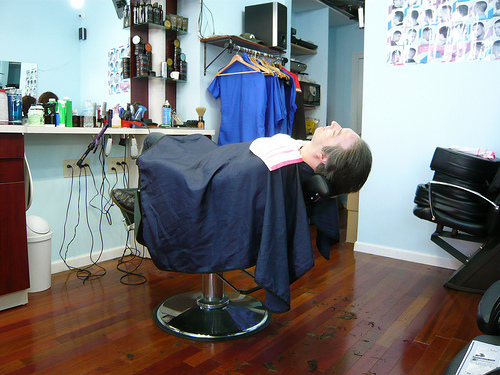<image>
Is the person on the ground? No. The person is not positioned on the ground. They may be near each other, but the person is not supported by or resting on top of the ground. Where is the man in relation to the chair? Is it behind the chair? No. The man is not behind the chair. From this viewpoint, the man appears to be positioned elsewhere in the scene. Is there a shirt next to the glass? No. The shirt is not positioned next to the glass. They are located in different areas of the scene. 